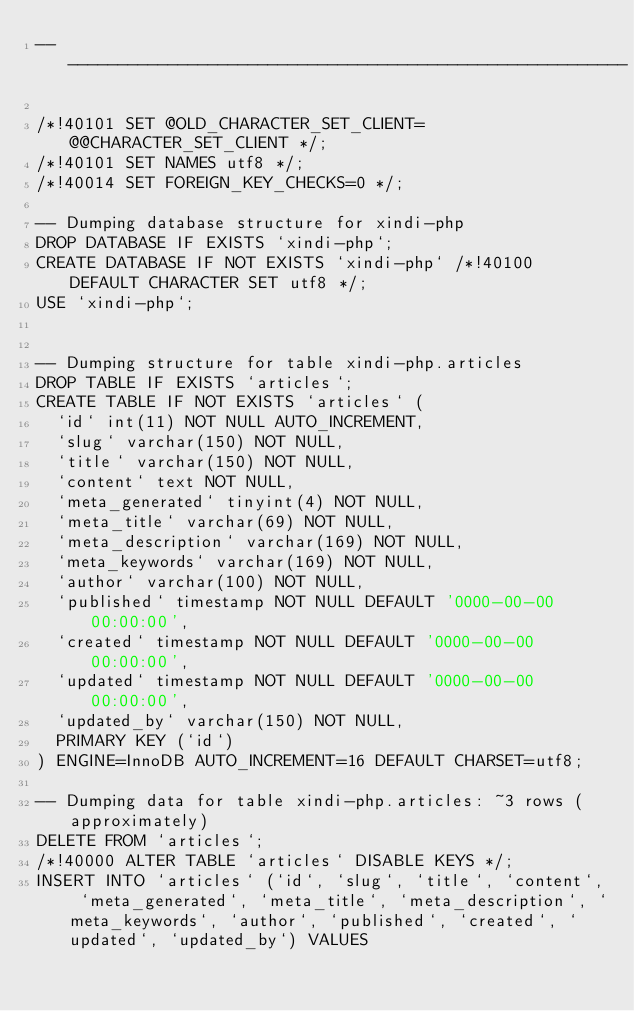Convert code to text. <code><loc_0><loc_0><loc_500><loc_500><_SQL_>-- --------------------------------------------------------

/*!40101 SET @OLD_CHARACTER_SET_CLIENT=@@CHARACTER_SET_CLIENT */;
/*!40101 SET NAMES utf8 */;
/*!40014 SET FOREIGN_KEY_CHECKS=0 */;

-- Dumping database structure for xindi-php
DROP DATABASE IF EXISTS `xindi-php`;
CREATE DATABASE IF NOT EXISTS `xindi-php` /*!40100 DEFAULT CHARACTER SET utf8 */;
USE `xindi-php`;


-- Dumping structure for table xindi-php.articles
DROP TABLE IF EXISTS `articles`;
CREATE TABLE IF NOT EXISTS `articles` (
  `id` int(11) NOT NULL AUTO_INCREMENT,
  `slug` varchar(150) NOT NULL,
  `title` varchar(150) NOT NULL,
  `content` text NOT NULL,
  `meta_generated` tinyint(4) NOT NULL,
  `meta_title` varchar(69) NOT NULL,
  `meta_description` varchar(169) NOT NULL,
  `meta_keywords` varchar(169) NOT NULL,
  `author` varchar(100) NOT NULL,
  `published` timestamp NOT NULL DEFAULT '0000-00-00 00:00:00',
  `created` timestamp NOT NULL DEFAULT '0000-00-00 00:00:00',
  `updated` timestamp NOT NULL DEFAULT '0000-00-00 00:00:00',
  `updated_by` varchar(150) NOT NULL,
  PRIMARY KEY (`id`)
) ENGINE=InnoDB AUTO_INCREMENT=16 DEFAULT CHARSET=utf8;

-- Dumping data for table xindi-php.articles: ~3 rows (approximately)
DELETE FROM `articles`;
/*!40000 ALTER TABLE `articles` DISABLE KEYS */;
INSERT INTO `articles` (`id`, `slug`, `title`, `content`, `meta_generated`, `meta_title`, `meta_description`, `meta_keywords`, `author`, `published`, `created`, `updated`, `updated_by`) VALUES</code> 